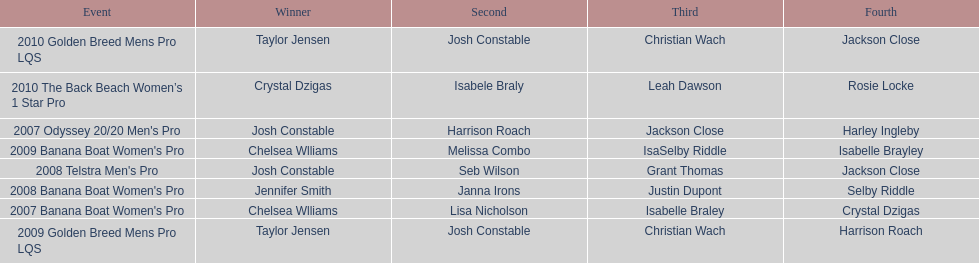Who was the top performer in the 2008 telstra men's pro? Josh Constable. 